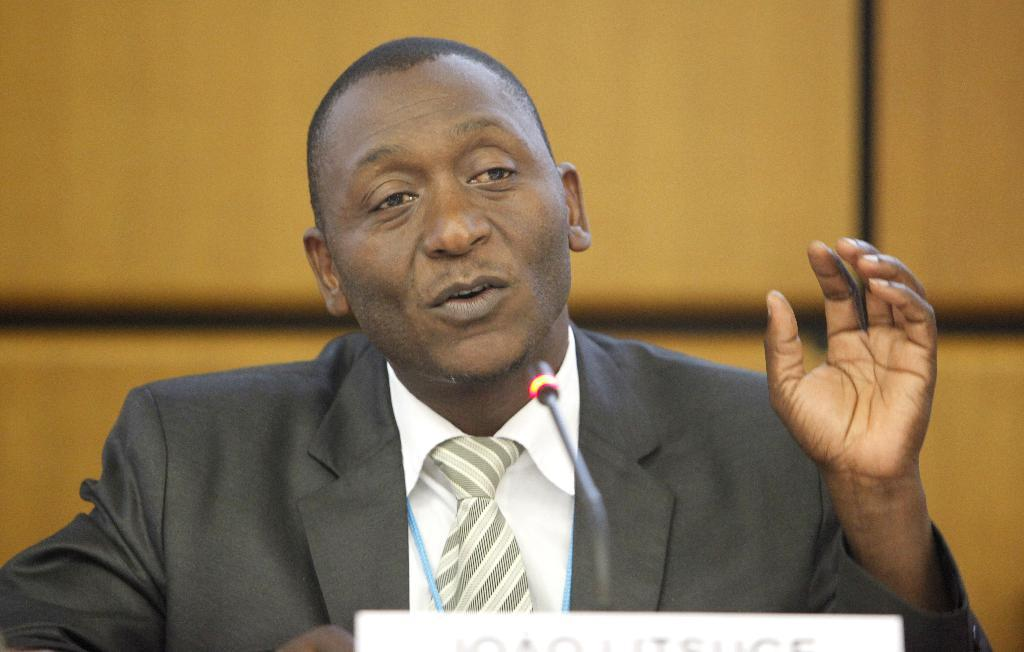Who is the main subject in the image? There is a man in the image. What is the man doing in the image? The man is sitting in front of a table and speaking. What object is in front of the man? There is a microphone in front of the man. Can you describe the background of the image? The background of the image is blurry. What type of jam is the man eating in the image? There is no jam present in the image; the man is speaking with a microphone in front of him. 